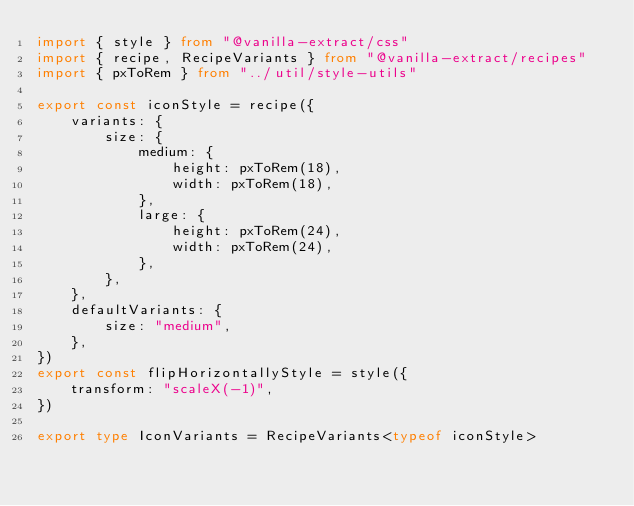<code> <loc_0><loc_0><loc_500><loc_500><_TypeScript_>import { style } from "@vanilla-extract/css"
import { recipe, RecipeVariants } from "@vanilla-extract/recipes"
import { pxToRem } from "../util/style-utils"

export const iconStyle = recipe({
	variants: {
		size: {
			medium: {
				height: pxToRem(18),
				width: pxToRem(18),
			},
			large: {
				height: pxToRem(24),
				width: pxToRem(24),
			},
		},
	},
	defaultVariants: {
		size: "medium",
	},
})
export const flipHorizontallyStyle = style({
	transform: "scaleX(-1)",
})

export type IconVariants = RecipeVariants<typeof iconStyle>
</code> 